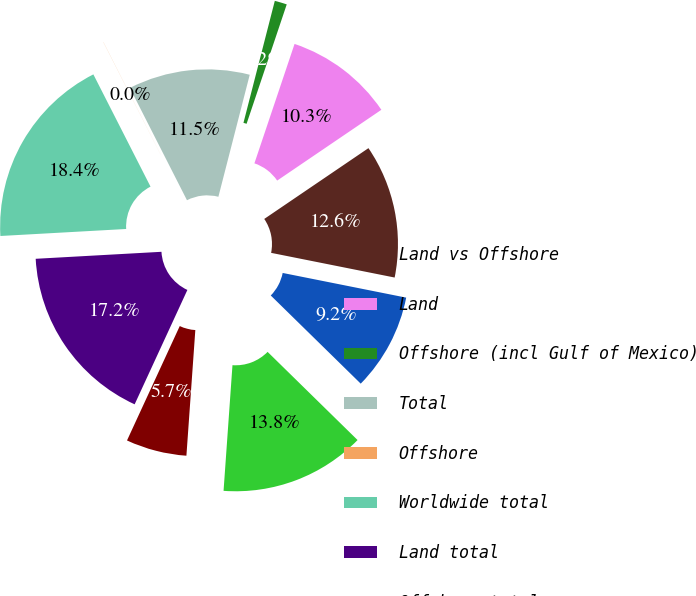Convert chart. <chart><loc_0><loc_0><loc_500><loc_500><pie_chart><fcel>Land vs Offshore<fcel>Land<fcel>Offshore (incl Gulf of Mexico)<fcel>Total<fcel>Offshore<fcel>Worldwide total<fcel>Land total<fcel>Offshore total<fcel>Oil vs Natural Gas<fcel>Oil<nl><fcel>12.64%<fcel>10.34%<fcel>1.16%<fcel>11.49%<fcel>0.01%<fcel>18.39%<fcel>17.24%<fcel>5.75%<fcel>13.79%<fcel>9.2%<nl></chart> 